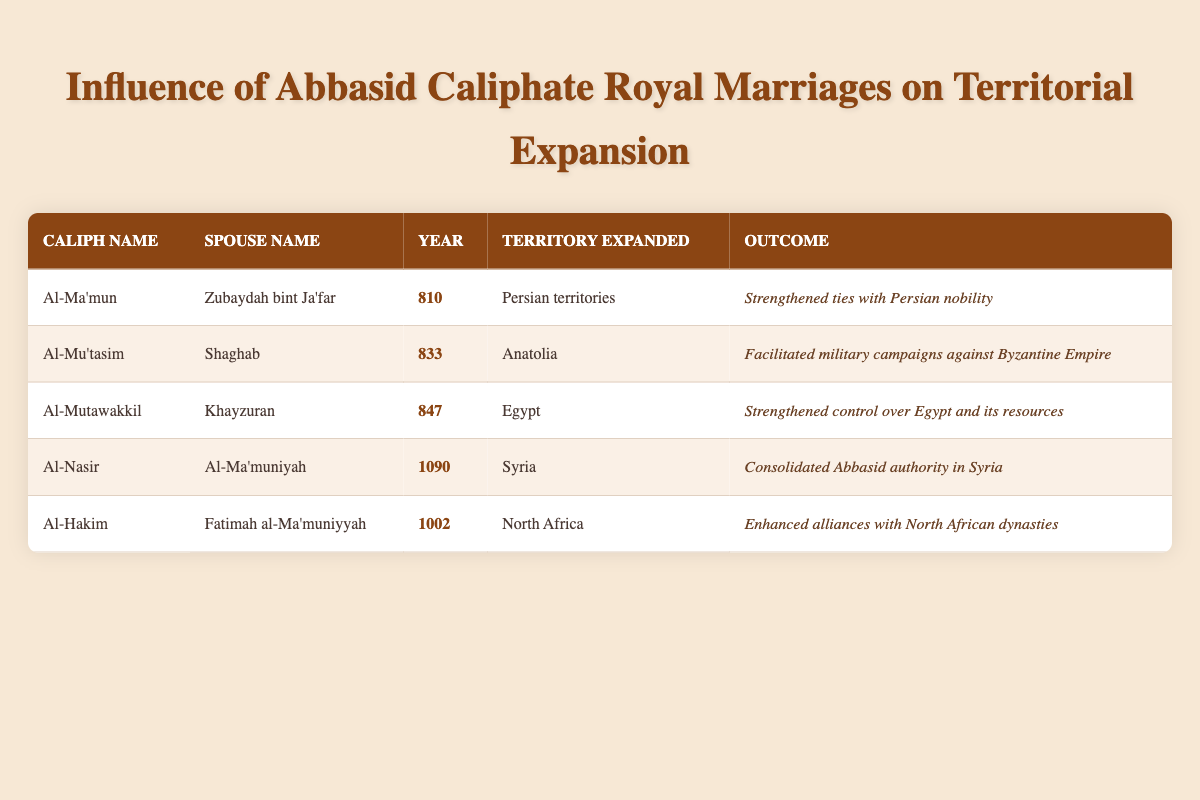What was the outcome of Al-Ma'mun's marriage to Zubaydah bint Ja'far? The table indicates that the outcome of Al-Ma'mun's marriage to Zubaydah bint Ja'far was the strengthening of ties with Persian nobility.
Answer: Strengthened ties with Persian nobility Which territory was expanded as a result of Al-Hakim's marriage? According to the table, Al-Hakim's marriage to Fatimah al-Ma'muniyyah led to the expansion into North Africa.
Answer: North Africa How many royal marriages led to the expansion of territory in the year 1002 or later? The table shows two royal marriages in that time frame: Al-Hakim's in 1002 and Al-Nasir's in 1090, giving a total of two.
Answer: 2 Did Al-Mu'tasim's marriage aid in military campaigns against the Byzantine Empire? Yes, the table explicitly states that Al-Mu'tasim's marriage to Shaghab facilitated military campaigns against the Byzantine Empire.
Answer: Yes Which caliph's marriage resulted in control over Egypt? The table indicates that Al-Mutawakkil's marriage to Khayzuran resulted in strengthened control over Egypt.
Answer: Al-Mutawakkil What is the relationship between the territories expanded and the caliphs who married in the 800s? The table shows that Al-Ma'mun expanded into Persian territories in 810 and Al-Mu'tasim expanded into Anatolia in 833, indicating both caliphs saw territorial expansion in the 800s through marriages.
Answer: Al-Ma'mun and Al-Mu'tasim both expanded territories Which territory had the latest expansion due to royal marriage? The most recent marriage in the table is Al-Nasir to Al-Ma'muniyah in 1090, which expanded into Syria, making it the latest territorial expansion.
Answer: Syria How many territories were expanded due to marriages from 800 to 900? There were three marriages leading to territorial expansion in this range: Al-Ma'mun (Persian territories in 810), Al-Mu'tasim (Anatolia in 833), and Al-Mutawakkil (Egypt in 847), totaling three territories.
Answer: 3 Did the royal marriages primarily strengthen alliances with local nobility? Yes, the table suggests that many of the outcomes, such as strengthening ties and consolidating authority, indicate a pattern of tightening alliances with local powers.
Answer: Yes 